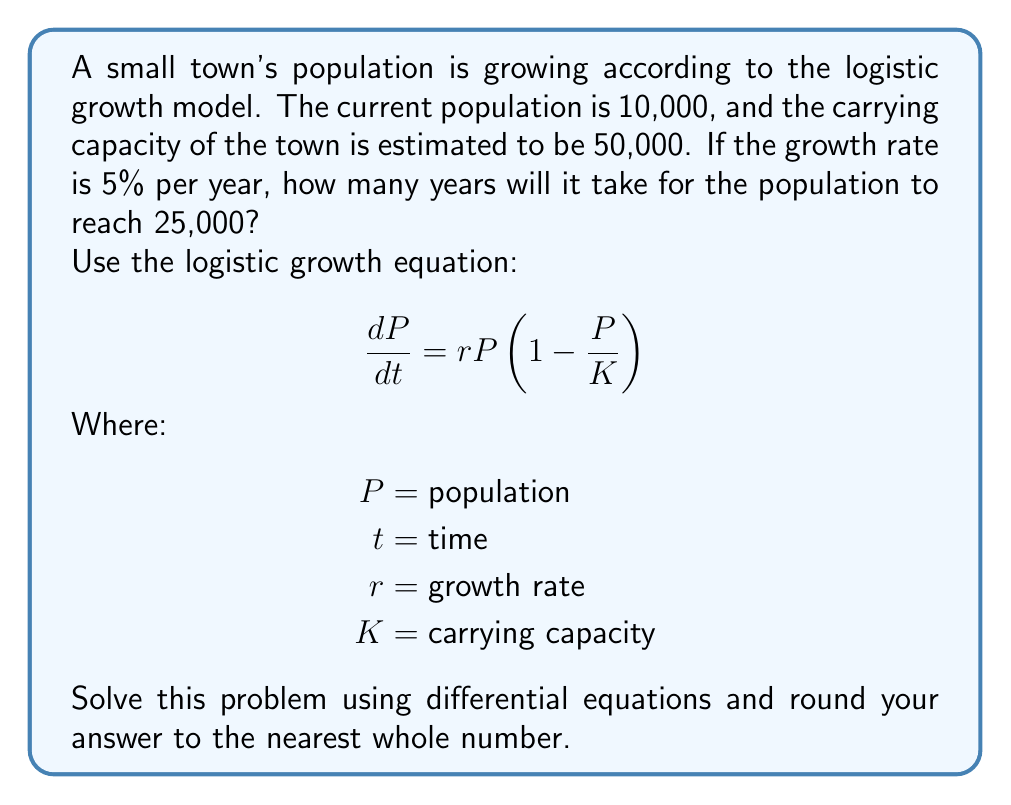Provide a solution to this math problem. To solve this problem, we need to use the logistic growth model and integrate the differential equation.

1) First, let's set up the equation with the given values:
   $r = 0.05$ (5% growth rate)
   $K = 50,000$ (carrying capacity)
   $P_0 = 10,000$ (initial population)
   $P = 25,000$ (target population)

2) The logistic growth equation in its integrated form is:

   $$P(t) = \frac{K}{1 + (\frac{K}{P_0} - 1)e^{-rt}}$$

3) We want to find $t$ when $P(t) = 25,000$. Let's substitute our values:

   $$25,000 = \frac{50,000}{1 + (\frac{50,000}{10,000} - 1)e^{-0.05t}}$$

4) Simplify:

   $$25,000 = \frac{50,000}{1 + 4e^{-0.05t}}$$

5) Multiply both sides by $(1 + 4e^{-0.05t})$:

   $$25,000(1 + 4e^{-0.05t}) = 50,000$$

6) Expand:

   $$25,000 + 100,000e^{-0.05t} = 50,000$$

7) Subtract 25,000 from both sides:

   $$100,000e^{-0.05t} = 25,000$$

8) Divide both sides by 100,000:

   $$e^{-0.05t} = 0.25$$

9) Take the natural log of both sides:

   $$-0.05t = \ln(0.25)$$

10) Solve for $t$:

    $$t = \frac{\ln(0.25)}{-0.05} \approx 27.73$$

11) Rounding to the nearest whole number:

    $$t \approx 28$$

Therefore, it will take approximately 28 years for the population to reach 25,000.
Answer: 28 years 